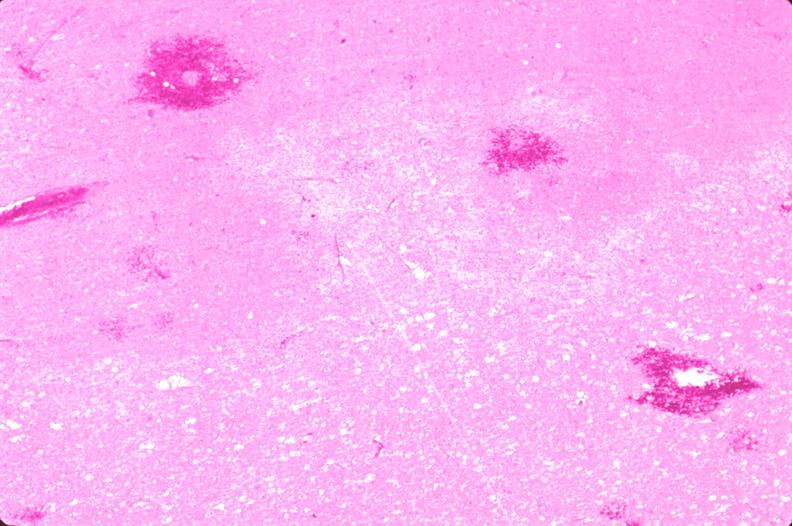what is present?
Answer the question using a single word or phrase. Nervous 